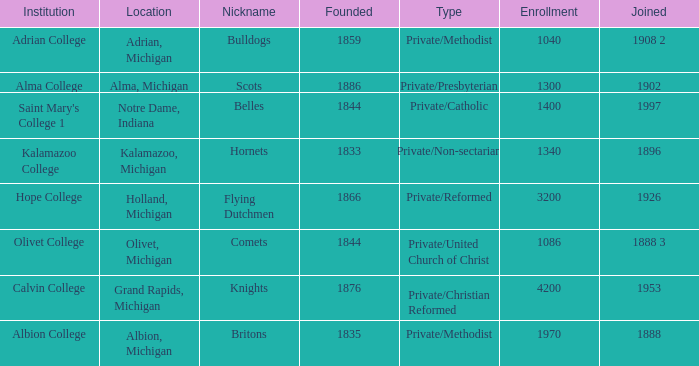In 1953, which of the institutions joined? Calvin College. 